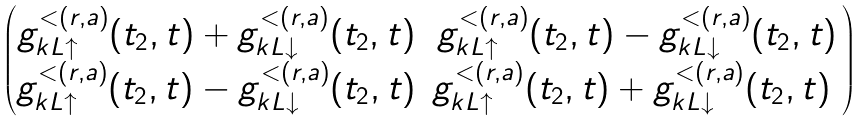Convert formula to latex. <formula><loc_0><loc_0><loc_500><loc_500>\begin{pmatrix} g _ { k L \uparrow } ^ { < ( r , a ) } ( t _ { 2 } , t ) + g _ { k L \downarrow } ^ { < ( r , a ) } ( t _ { 2 } , t ) & g _ { k L \uparrow } ^ { < ( r , a ) } ( t _ { 2 } , t ) - g _ { k L \downarrow } ^ { < ( r , a ) } ( t _ { 2 } , t ) \\ g _ { k L \uparrow } ^ { < ( r , a ) } ( t _ { 2 } , t ) - g _ { k L \downarrow } ^ { < ( r , a ) } ( t _ { 2 } , t ) & g _ { k L \uparrow } ^ { < ( r , a ) } ( t _ { 2 } , t ) + g _ { k L \downarrow } ^ { < ( r , a ) } ( t _ { 2 } , t ) \ \end{pmatrix}</formula> 